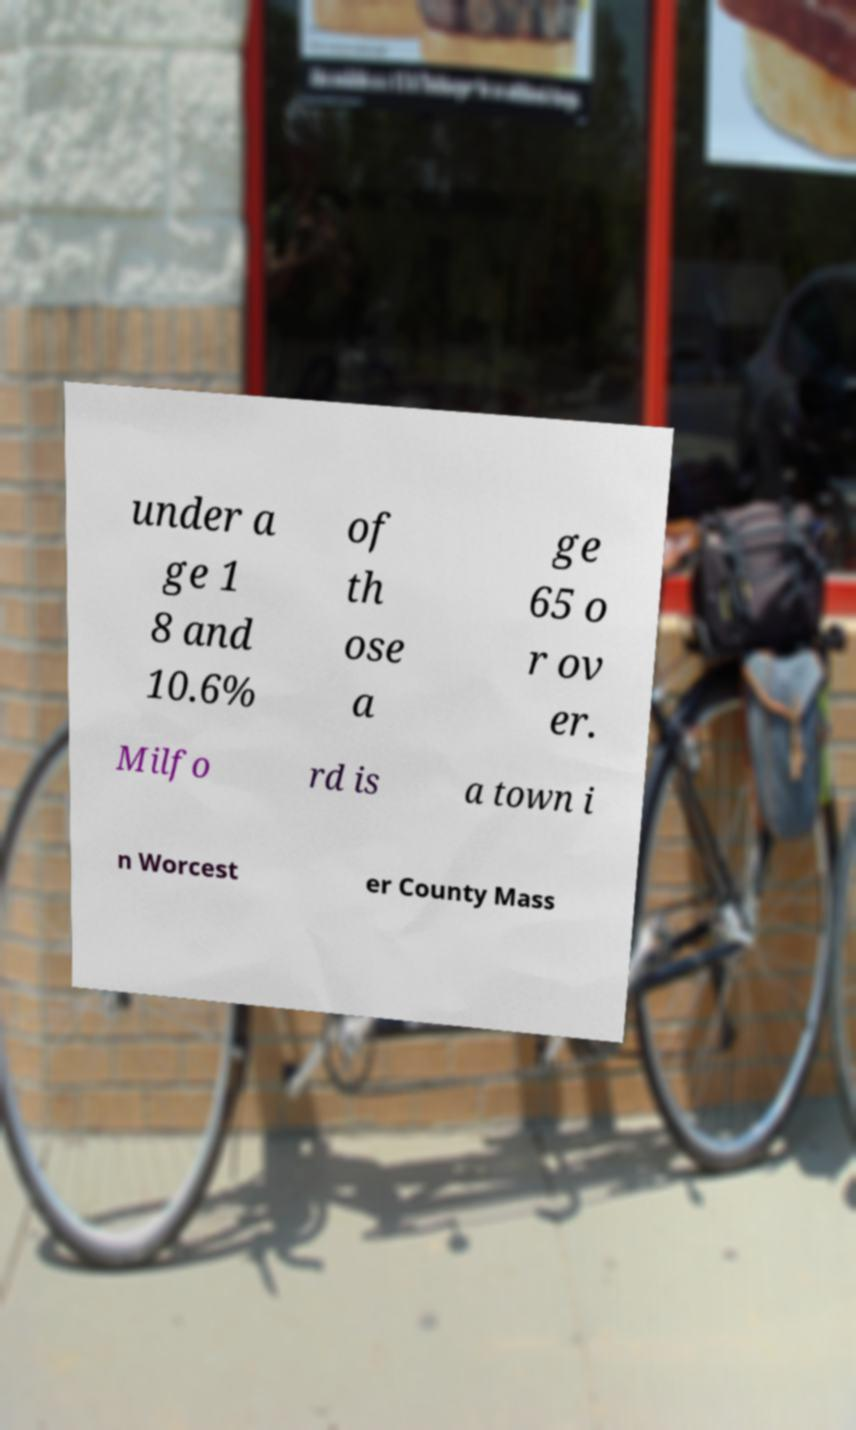Can you read and provide the text displayed in the image?This photo seems to have some interesting text. Can you extract and type it out for me? under a ge 1 8 and 10.6% of th ose a ge 65 o r ov er. Milfo rd is a town i n Worcest er County Mass 